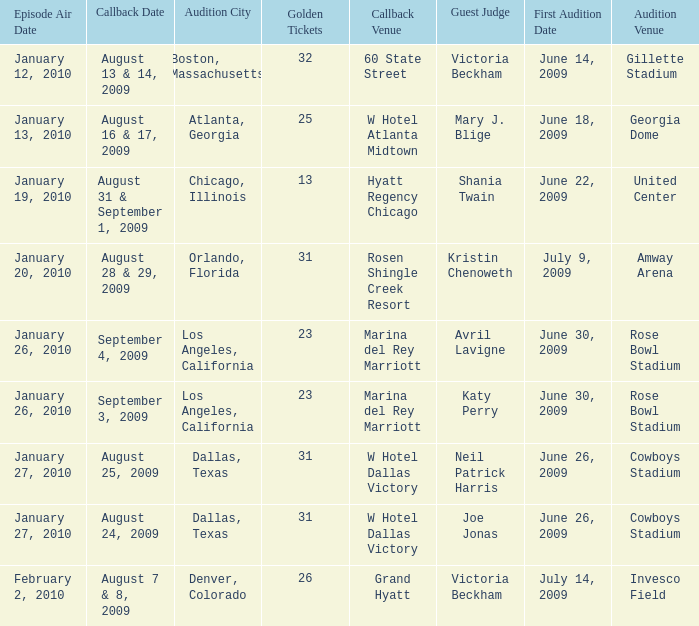Name the guest judge for first audition date being july 9, 2009 1.0. 